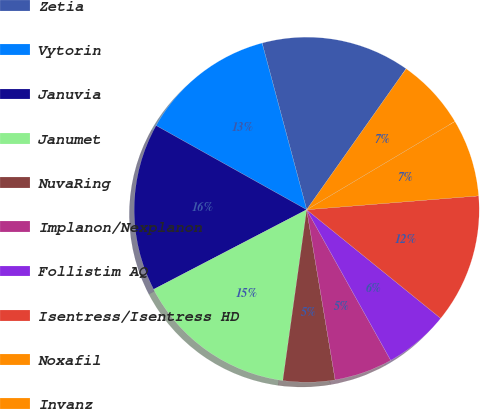Convert chart to OTSL. <chart><loc_0><loc_0><loc_500><loc_500><pie_chart><fcel>Zetia<fcel>Vytorin<fcel>Januvia<fcel>Janumet<fcel>NuvaRing<fcel>Implanon/Nexplanon<fcel>Follistim AQ<fcel>Isentress/Isentress HD<fcel>Noxafil<fcel>Invanz<nl><fcel>13.94%<fcel>12.73%<fcel>15.75%<fcel>15.15%<fcel>4.85%<fcel>5.46%<fcel>6.06%<fcel>12.12%<fcel>7.27%<fcel>6.67%<nl></chart> 